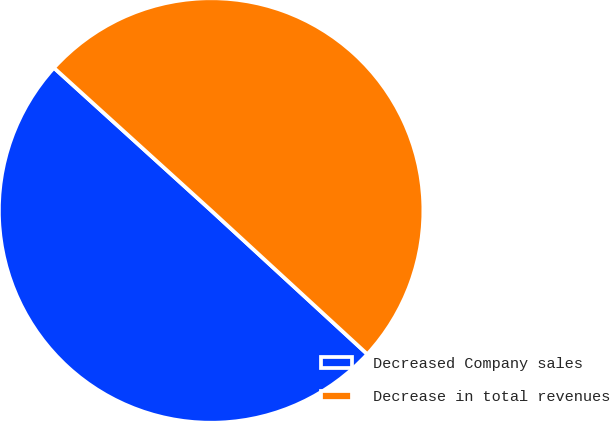Convert chart. <chart><loc_0><loc_0><loc_500><loc_500><pie_chart><fcel>Decreased Company sales<fcel>Decrease in total revenues<nl><fcel>49.89%<fcel>50.11%<nl></chart> 